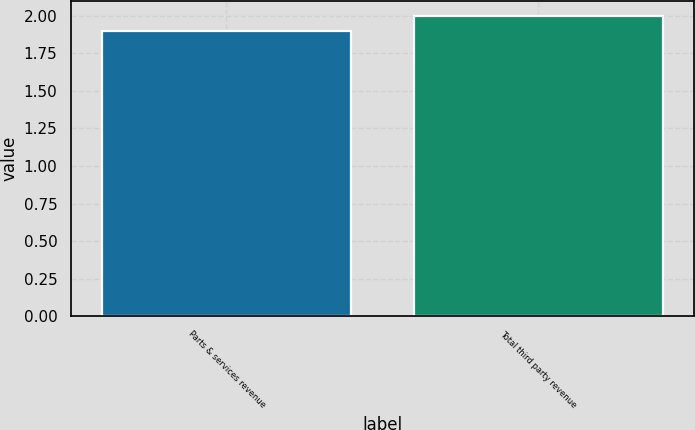Convert chart to OTSL. <chart><loc_0><loc_0><loc_500><loc_500><bar_chart><fcel>Parts & services revenue<fcel>Total third party revenue<nl><fcel>1.9<fcel>2<nl></chart> 